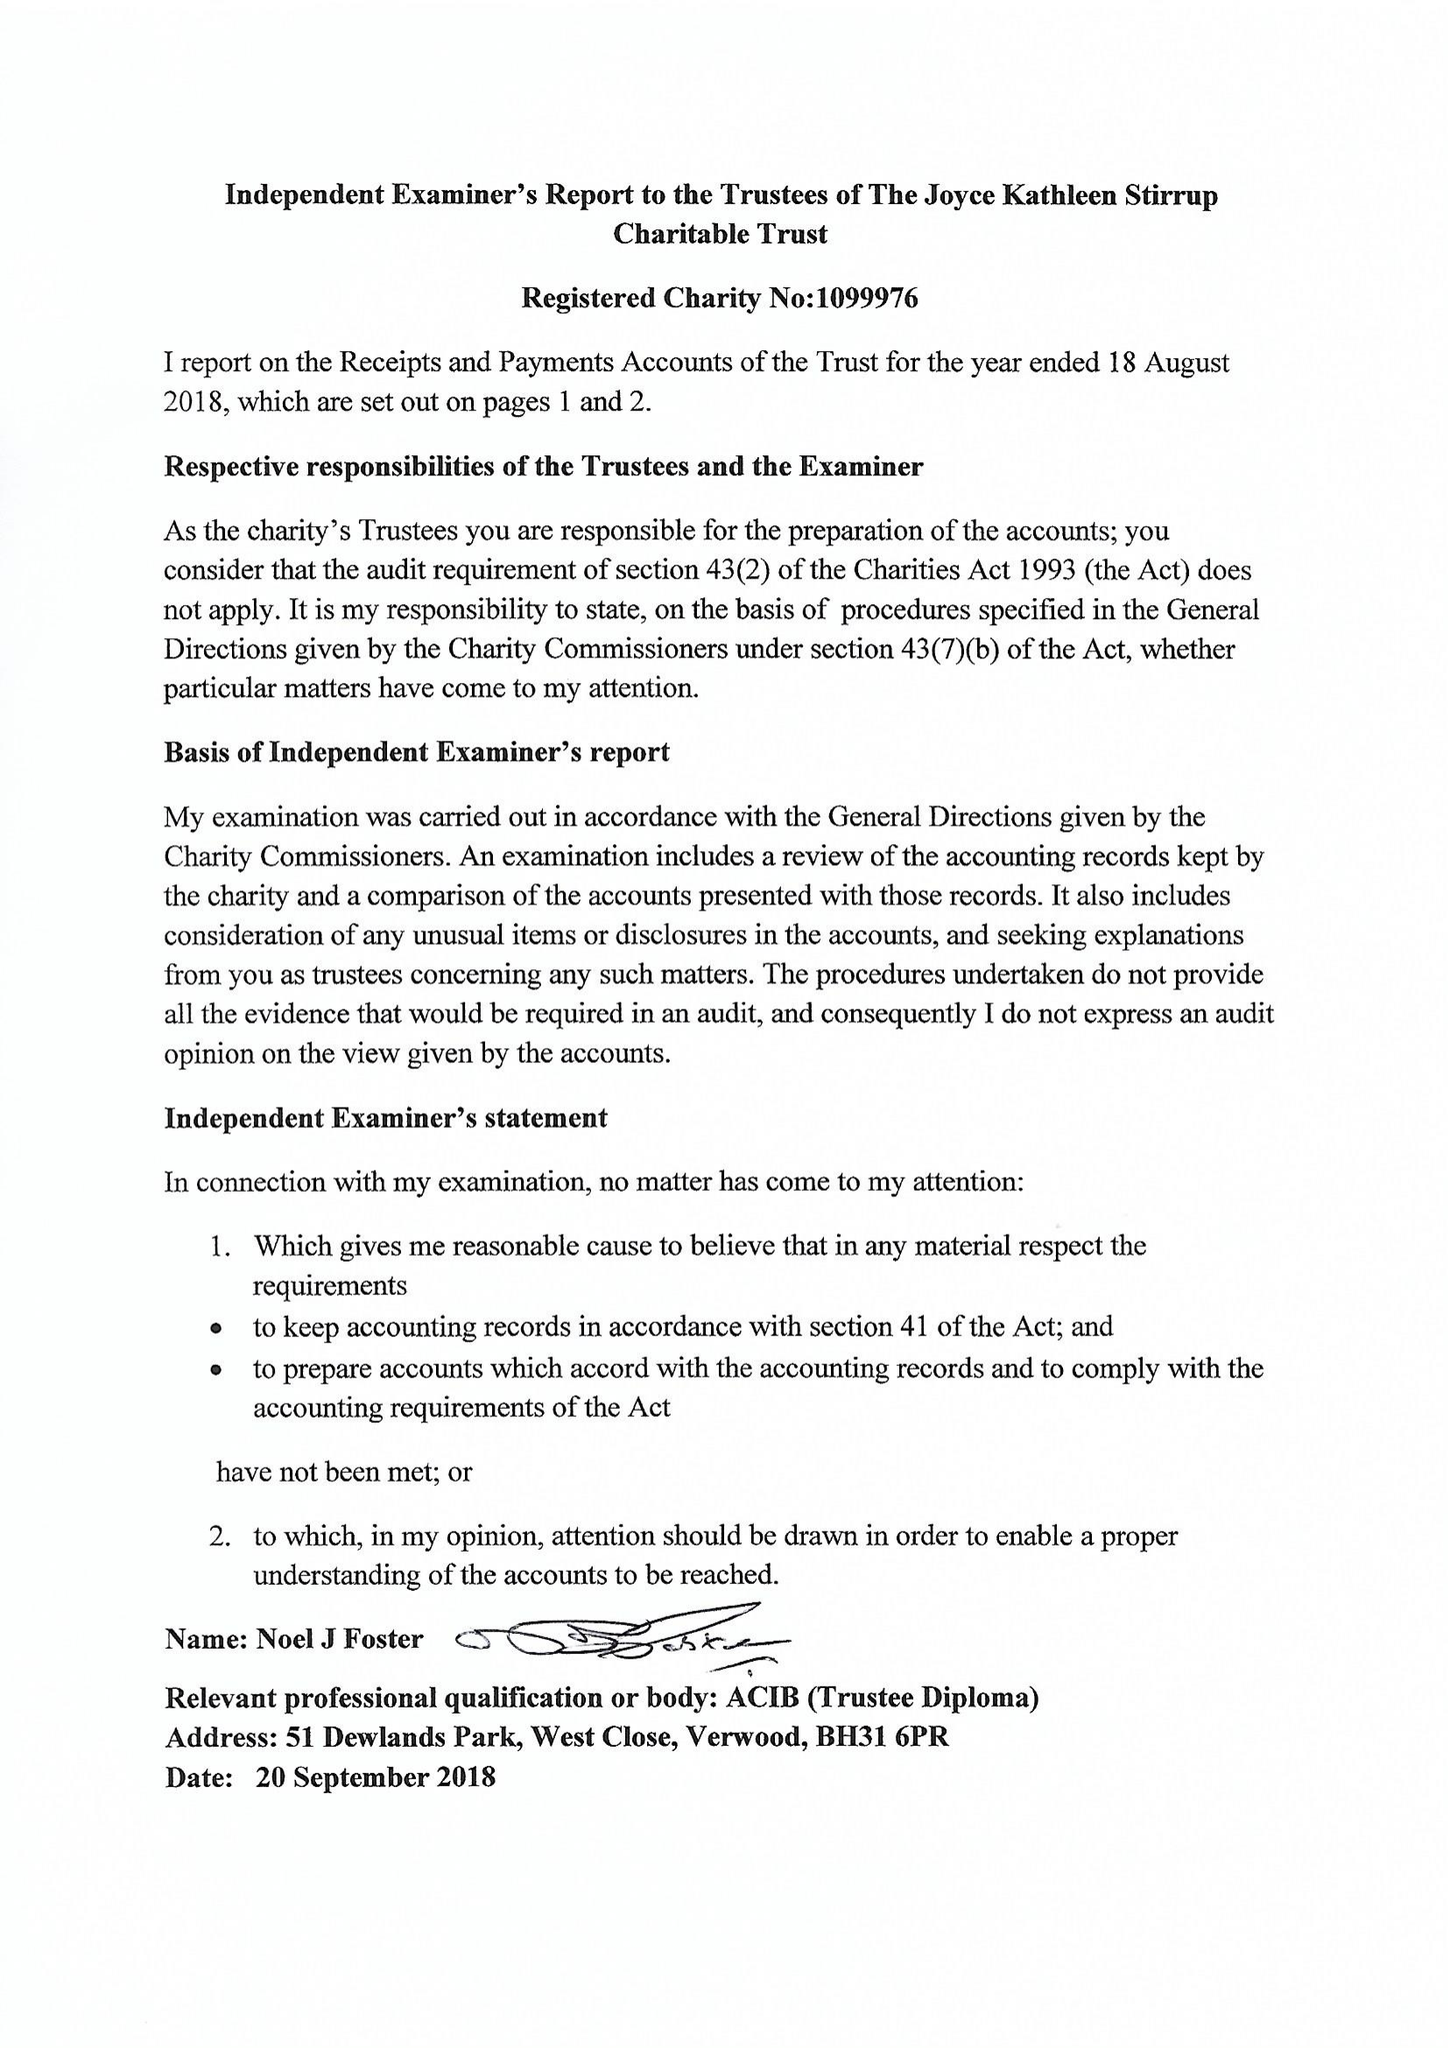What is the value for the income_annually_in_british_pounds?
Answer the question using a single word or phrase. 134966.00 